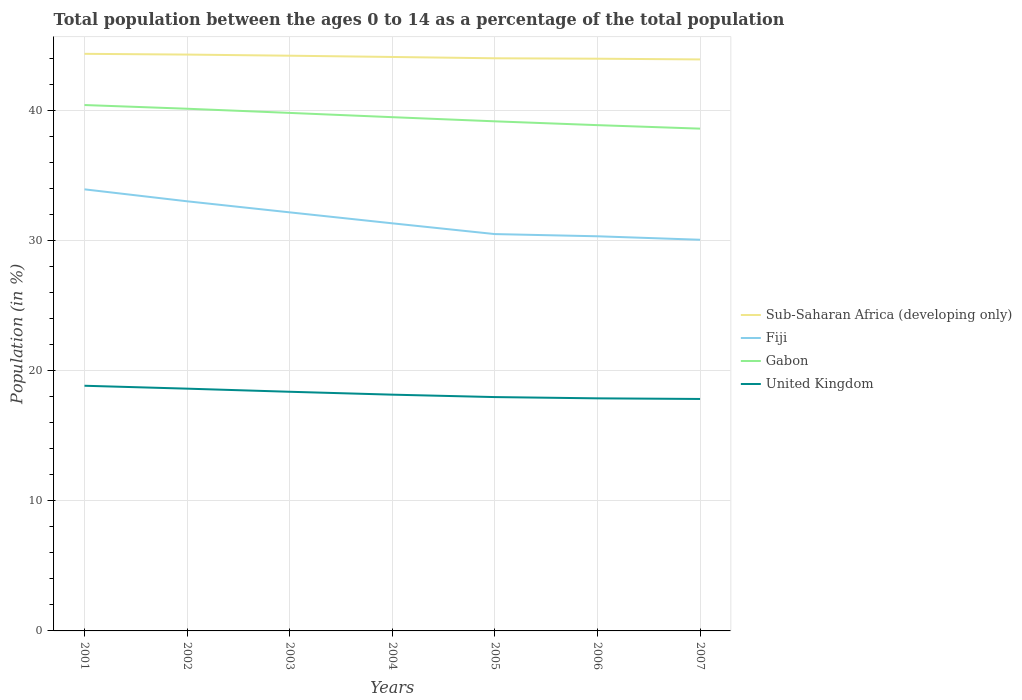Across all years, what is the maximum percentage of the population ages 0 to 14 in Fiji?
Make the answer very short. 30.09. What is the total percentage of the population ages 0 to 14 in Sub-Saharan Africa (developing only) in the graph?
Your answer should be compact. 0.1. What is the difference between the highest and the second highest percentage of the population ages 0 to 14 in Gabon?
Your response must be concise. 1.82. How many years are there in the graph?
Keep it short and to the point. 7. What is the difference between two consecutive major ticks on the Y-axis?
Your answer should be very brief. 10. Does the graph contain grids?
Make the answer very short. Yes. How are the legend labels stacked?
Your answer should be compact. Vertical. What is the title of the graph?
Give a very brief answer. Total population between the ages 0 to 14 as a percentage of the total population. What is the Population (in %) of Sub-Saharan Africa (developing only) in 2001?
Make the answer very short. 44.4. What is the Population (in %) of Fiji in 2001?
Keep it short and to the point. 33.97. What is the Population (in %) of Gabon in 2001?
Keep it short and to the point. 40.46. What is the Population (in %) in United Kingdom in 2001?
Give a very brief answer. 18.86. What is the Population (in %) in Sub-Saharan Africa (developing only) in 2002?
Provide a short and direct response. 44.34. What is the Population (in %) of Fiji in 2002?
Ensure brevity in your answer.  33.05. What is the Population (in %) of Gabon in 2002?
Provide a succinct answer. 40.17. What is the Population (in %) in United Kingdom in 2002?
Ensure brevity in your answer.  18.64. What is the Population (in %) in Sub-Saharan Africa (developing only) in 2003?
Your answer should be compact. 44.25. What is the Population (in %) of Fiji in 2003?
Your answer should be compact. 32.2. What is the Population (in %) in Gabon in 2003?
Offer a very short reply. 39.85. What is the Population (in %) of United Kingdom in 2003?
Make the answer very short. 18.4. What is the Population (in %) of Sub-Saharan Africa (developing only) in 2004?
Offer a terse response. 44.15. What is the Population (in %) of Fiji in 2004?
Provide a succinct answer. 31.36. What is the Population (in %) in Gabon in 2004?
Ensure brevity in your answer.  39.52. What is the Population (in %) of United Kingdom in 2004?
Provide a succinct answer. 18.18. What is the Population (in %) of Sub-Saharan Africa (developing only) in 2005?
Your answer should be compact. 44.05. What is the Population (in %) in Fiji in 2005?
Your answer should be compact. 30.53. What is the Population (in %) in Gabon in 2005?
Your answer should be very brief. 39.2. What is the Population (in %) in United Kingdom in 2005?
Give a very brief answer. 17.99. What is the Population (in %) of Sub-Saharan Africa (developing only) in 2006?
Offer a very short reply. 44.02. What is the Population (in %) of Fiji in 2006?
Keep it short and to the point. 30.36. What is the Population (in %) in Gabon in 2006?
Give a very brief answer. 38.91. What is the Population (in %) in United Kingdom in 2006?
Offer a terse response. 17.89. What is the Population (in %) in Sub-Saharan Africa (developing only) in 2007?
Your response must be concise. 43.97. What is the Population (in %) in Fiji in 2007?
Make the answer very short. 30.09. What is the Population (in %) in Gabon in 2007?
Provide a short and direct response. 38.64. What is the Population (in %) of United Kingdom in 2007?
Your answer should be compact. 17.84. Across all years, what is the maximum Population (in %) in Sub-Saharan Africa (developing only)?
Give a very brief answer. 44.4. Across all years, what is the maximum Population (in %) in Fiji?
Your response must be concise. 33.97. Across all years, what is the maximum Population (in %) in Gabon?
Offer a terse response. 40.46. Across all years, what is the maximum Population (in %) of United Kingdom?
Your answer should be compact. 18.86. Across all years, what is the minimum Population (in %) of Sub-Saharan Africa (developing only)?
Provide a succinct answer. 43.97. Across all years, what is the minimum Population (in %) of Fiji?
Your answer should be very brief. 30.09. Across all years, what is the minimum Population (in %) in Gabon?
Provide a succinct answer. 38.64. Across all years, what is the minimum Population (in %) of United Kingdom?
Offer a terse response. 17.84. What is the total Population (in %) of Sub-Saharan Africa (developing only) in the graph?
Your answer should be compact. 309.18. What is the total Population (in %) of Fiji in the graph?
Provide a short and direct response. 221.56. What is the total Population (in %) in Gabon in the graph?
Make the answer very short. 276.75. What is the total Population (in %) in United Kingdom in the graph?
Make the answer very short. 127.8. What is the difference between the Population (in %) of Sub-Saharan Africa (developing only) in 2001 and that in 2002?
Offer a terse response. 0.06. What is the difference between the Population (in %) of Gabon in 2001 and that in 2002?
Offer a very short reply. 0.29. What is the difference between the Population (in %) of United Kingdom in 2001 and that in 2002?
Make the answer very short. 0.22. What is the difference between the Population (in %) of Sub-Saharan Africa (developing only) in 2001 and that in 2003?
Your response must be concise. 0.14. What is the difference between the Population (in %) of Fiji in 2001 and that in 2003?
Ensure brevity in your answer.  1.77. What is the difference between the Population (in %) in Gabon in 2001 and that in 2003?
Provide a short and direct response. 0.61. What is the difference between the Population (in %) of United Kingdom in 2001 and that in 2003?
Ensure brevity in your answer.  0.46. What is the difference between the Population (in %) in Sub-Saharan Africa (developing only) in 2001 and that in 2004?
Give a very brief answer. 0.24. What is the difference between the Population (in %) of Fiji in 2001 and that in 2004?
Make the answer very short. 2.61. What is the difference between the Population (in %) in Gabon in 2001 and that in 2004?
Offer a very short reply. 0.93. What is the difference between the Population (in %) in United Kingdom in 2001 and that in 2004?
Keep it short and to the point. 0.69. What is the difference between the Population (in %) of Sub-Saharan Africa (developing only) in 2001 and that in 2005?
Ensure brevity in your answer.  0.34. What is the difference between the Population (in %) of Fiji in 2001 and that in 2005?
Make the answer very short. 3.44. What is the difference between the Population (in %) in Gabon in 2001 and that in 2005?
Your answer should be very brief. 1.25. What is the difference between the Population (in %) of United Kingdom in 2001 and that in 2005?
Keep it short and to the point. 0.87. What is the difference between the Population (in %) in Sub-Saharan Africa (developing only) in 2001 and that in 2006?
Ensure brevity in your answer.  0.37. What is the difference between the Population (in %) in Fiji in 2001 and that in 2006?
Make the answer very short. 3.61. What is the difference between the Population (in %) of Gabon in 2001 and that in 2006?
Provide a short and direct response. 1.55. What is the difference between the Population (in %) of United Kingdom in 2001 and that in 2006?
Make the answer very short. 0.97. What is the difference between the Population (in %) in Sub-Saharan Africa (developing only) in 2001 and that in 2007?
Provide a short and direct response. 0.43. What is the difference between the Population (in %) in Fiji in 2001 and that in 2007?
Your answer should be compact. 3.88. What is the difference between the Population (in %) in Gabon in 2001 and that in 2007?
Make the answer very short. 1.82. What is the difference between the Population (in %) in United Kingdom in 2001 and that in 2007?
Make the answer very short. 1.02. What is the difference between the Population (in %) in Sub-Saharan Africa (developing only) in 2002 and that in 2003?
Provide a succinct answer. 0.09. What is the difference between the Population (in %) in Fiji in 2002 and that in 2003?
Provide a succinct answer. 0.85. What is the difference between the Population (in %) of Gabon in 2002 and that in 2003?
Provide a succinct answer. 0.32. What is the difference between the Population (in %) in United Kingdom in 2002 and that in 2003?
Ensure brevity in your answer.  0.24. What is the difference between the Population (in %) in Sub-Saharan Africa (developing only) in 2002 and that in 2004?
Give a very brief answer. 0.18. What is the difference between the Population (in %) of Fiji in 2002 and that in 2004?
Offer a terse response. 1.69. What is the difference between the Population (in %) of Gabon in 2002 and that in 2004?
Offer a very short reply. 0.65. What is the difference between the Population (in %) of United Kingdom in 2002 and that in 2004?
Your answer should be compact. 0.46. What is the difference between the Population (in %) in Sub-Saharan Africa (developing only) in 2002 and that in 2005?
Give a very brief answer. 0.28. What is the difference between the Population (in %) of Fiji in 2002 and that in 2005?
Offer a very short reply. 2.52. What is the difference between the Population (in %) in Gabon in 2002 and that in 2005?
Your answer should be very brief. 0.97. What is the difference between the Population (in %) of United Kingdom in 2002 and that in 2005?
Offer a terse response. 0.65. What is the difference between the Population (in %) in Sub-Saharan Africa (developing only) in 2002 and that in 2006?
Keep it short and to the point. 0.32. What is the difference between the Population (in %) in Fiji in 2002 and that in 2006?
Give a very brief answer. 2.69. What is the difference between the Population (in %) of Gabon in 2002 and that in 2006?
Make the answer very short. 1.26. What is the difference between the Population (in %) of United Kingdom in 2002 and that in 2006?
Your answer should be very brief. 0.75. What is the difference between the Population (in %) of Sub-Saharan Africa (developing only) in 2002 and that in 2007?
Give a very brief answer. 0.37. What is the difference between the Population (in %) of Fiji in 2002 and that in 2007?
Your response must be concise. 2.96. What is the difference between the Population (in %) of Gabon in 2002 and that in 2007?
Your answer should be very brief. 1.53. What is the difference between the Population (in %) of United Kingdom in 2002 and that in 2007?
Ensure brevity in your answer.  0.79. What is the difference between the Population (in %) of Sub-Saharan Africa (developing only) in 2003 and that in 2004?
Your answer should be very brief. 0.1. What is the difference between the Population (in %) in Fiji in 2003 and that in 2004?
Ensure brevity in your answer.  0.84. What is the difference between the Population (in %) in Gabon in 2003 and that in 2004?
Ensure brevity in your answer.  0.33. What is the difference between the Population (in %) in United Kingdom in 2003 and that in 2004?
Your answer should be very brief. 0.22. What is the difference between the Population (in %) in Sub-Saharan Africa (developing only) in 2003 and that in 2005?
Provide a succinct answer. 0.2. What is the difference between the Population (in %) in Fiji in 2003 and that in 2005?
Provide a short and direct response. 1.67. What is the difference between the Population (in %) in Gabon in 2003 and that in 2005?
Provide a succinct answer. 0.65. What is the difference between the Population (in %) of United Kingdom in 2003 and that in 2005?
Offer a terse response. 0.41. What is the difference between the Population (in %) in Sub-Saharan Africa (developing only) in 2003 and that in 2006?
Give a very brief answer. 0.23. What is the difference between the Population (in %) of Fiji in 2003 and that in 2006?
Offer a terse response. 1.84. What is the difference between the Population (in %) of Gabon in 2003 and that in 2006?
Offer a very short reply. 0.94. What is the difference between the Population (in %) of United Kingdom in 2003 and that in 2006?
Your answer should be very brief. 0.51. What is the difference between the Population (in %) of Sub-Saharan Africa (developing only) in 2003 and that in 2007?
Provide a succinct answer. 0.29. What is the difference between the Population (in %) in Fiji in 2003 and that in 2007?
Your answer should be compact. 2.11. What is the difference between the Population (in %) in Gabon in 2003 and that in 2007?
Offer a very short reply. 1.21. What is the difference between the Population (in %) in United Kingdom in 2003 and that in 2007?
Give a very brief answer. 0.55. What is the difference between the Population (in %) of Sub-Saharan Africa (developing only) in 2004 and that in 2005?
Keep it short and to the point. 0.1. What is the difference between the Population (in %) of Fiji in 2004 and that in 2005?
Provide a succinct answer. 0.83. What is the difference between the Population (in %) in Gabon in 2004 and that in 2005?
Your response must be concise. 0.32. What is the difference between the Population (in %) of United Kingdom in 2004 and that in 2005?
Ensure brevity in your answer.  0.19. What is the difference between the Population (in %) of Sub-Saharan Africa (developing only) in 2004 and that in 2006?
Your response must be concise. 0.13. What is the difference between the Population (in %) in Gabon in 2004 and that in 2006?
Your response must be concise. 0.61. What is the difference between the Population (in %) of United Kingdom in 2004 and that in 2006?
Give a very brief answer. 0.28. What is the difference between the Population (in %) of Sub-Saharan Africa (developing only) in 2004 and that in 2007?
Offer a very short reply. 0.19. What is the difference between the Population (in %) of Fiji in 2004 and that in 2007?
Provide a short and direct response. 1.26. What is the difference between the Population (in %) in Gabon in 2004 and that in 2007?
Your answer should be compact. 0.88. What is the difference between the Population (in %) of United Kingdom in 2004 and that in 2007?
Ensure brevity in your answer.  0.33. What is the difference between the Population (in %) in Sub-Saharan Africa (developing only) in 2005 and that in 2006?
Your response must be concise. 0.03. What is the difference between the Population (in %) of Fiji in 2005 and that in 2006?
Keep it short and to the point. 0.17. What is the difference between the Population (in %) in Gabon in 2005 and that in 2006?
Keep it short and to the point. 0.29. What is the difference between the Population (in %) in United Kingdom in 2005 and that in 2006?
Provide a short and direct response. 0.1. What is the difference between the Population (in %) of Sub-Saharan Africa (developing only) in 2005 and that in 2007?
Provide a short and direct response. 0.09. What is the difference between the Population (in %) of Fiji in 2005 and that in 2007?
Your answer should be very brief. 0.44. What is the difference between the Population (in %) in Gabon in 2005 and that in 2007?
Keep it short and to the point. 0.56. What is the difference between the Population (in %) in United Kingdom in 2005 and that in 2007?
Offer a terse response. 0.15. What is the difference between the Population (in %) in Sub-Saharan Africa (developing only) in 2006 and that in 2007?
Make the answer very short. 0.06. What is the difference between the Population (in %) in Fiji in 2006 and that in 2007?
Provide a short and direct response. 0.27. What is the difference between the Population (in %) in Gabon in 2006 and that in 2007?
Provide a succinct answer. 0.27. What is the difference between the Population (in %) in United Kingdom in 2006 and that in 2007?
Provide a short and direct response. 0.05. What is the difference between the Population (in %) of Sub-Saharan Africa (developing only) in 2001 and the Population (in %) of Fiji in 2002?
Offer a terse response. 11.34. What is the difference between the Population (in %) of Sub-Saharan Africa (developing only) in 2001 and the Population (in %) of Gabon in 2002?
Keep it short and to the point. 4.22. What is the difference between the Population (in %) of Sub-Saharan Africa (developing only) in 2001 and the Population (in %) of United Kingdom in 2002?
Your answer should be compact. 25.76. What is the difference between the Population (in %) in Fiji in 2001 and the Population (in %) in Gabon in 2002?
Your response must be concise. -6.2. What is the difference between the Population (in %) in Fiji in 2001 and the Population (in %) in United Kingdom in 2002?
Provide a short and direct response. 15.33. What is the difference between the Population (in %) of Gabon in 2001 and the Population (in %) of United Kingdom in 2002?
Make the answer very short. 21.82. What is the difference between the Population (in %) in Sub-Saharan Africa (developing only) in 2001 and the Population (in %) in Fiji in 2003?
Offer a terse response. 12.2. What is the difference between the Population (in %) of Sub-Saharan Africa (developing only) in 2001 and the Population (in %) of Gabon in 2003?
Ensure brevity in your answer.  4.54. What is the difference between the Population (in %) of Sub-Saharan Africa (developing only) in 2001 and the Population (in %) of United Kingdom in 2003?
Provide a succinct answer. 26. What is the difference between the Population (in %) of Fiji in 2001 and the Population (in %) of Gabon in 2003?
Give a very brief answer. -5.88. What is the difference between the Population (in %) in Fiji in 2001 and the Population (in %) in United Kingdom in 2003?
Offer a very short reply. 15.57. What is the difference between the Population (in %) of Gabon in 2001 and the Population (in %) of United Kingdom in 2003?
Give a very brief answer. 22.06. What is the difference between the Population (in %) in Sub-Saharan Africa (developing only) in 2001 and the Population (in %) in Fiji in 2004?
Give a very brief answer. 13.04. What is the difference between the Population (in %) in Sub-Saharan Africa (developing only) in 2001 and the Population (in %) in Gabon in 2004?
Give a very brief answer. 4.87. What is the difference between the Population (in %) of Sub-Saharan Africa (developing only) in 2001 and the Population (in %) of United Kingdom in 2004?
Ensure brevity in your answer.  26.22. What is the difference between the Population (in %) in Fiji in 2001 and the Population (in %) in Gabon in 2004?
Your answer should be compact. -5.55. What is the difference between the Population (in %) of Fiji in 2001 and the Population (in %) of United Kingdom in 2004?
Offer a terse response. 15.8. What is the difference between the Population (in %) of Gabon in 2001 and the Population (in %) of United Kingdom in 2004?
Make the answer very short. 22.28. What is the difference between the Population (in %) in Sub-Saharan Africa (developing only) in 2001 and the Population (in %) in Fiji in 2005?
Offer a terse response. 13.87. What is the difference between the Population (in %) in Sub-Saharan Africa (developing only) in 2001 and the Population (in %) in Gabon in 2005?
Provide a succinct answer. 5.19. What is the difference between the Population (in %) of Sub-Saharan Africa (developing only) in 2001 and the Population (in %) of United Kingdom in 2005?
Offer a very short reply. 26.41. What is the difference between the Population (in %) in Fiji in 2001 and the Population (in %) in Gabon in 2005?
Offer a very short reply. -5.23. What is the difference between the Population (in %) of Fiji in 2001 and the Population (in %) of United Kingdom in 2005?
Provide a succinct answer. 15.98. What is the difference between the Population (in %) of Gabon in 2001 and the Population (in %) of United Kingdom in 2005?
Your answer should be very brief. 22.47. What is the difference between the Population (in %) of Sub-Saharan Africa (developing only) in 2001 and the Population (in %) of Fiji in 2006?
Keep it short and to the point. 14.04. What is the difference between the Population (in %) of Sub-Saharan Africa (developing only) in 2001 and the Population (in %) of Gabon in 2006?
Offer a very short reply. 5.49. What is the difference between the Population (in %) of Sub-Saharan Africa (developing only) in 2001 and the Population (in %) of United Kingdom in 2006?
Your answer should be very brief. 26.5. What is the difference between the Population (in %) of Fiji in 2001 and the Population (in %) of Gabon in 2006?
Offer a very short reply. -4.94. What is the difference between the Population (in %) in Fiji in 2001 and the Population (in %) in United Kingdom in 2006?
Offer a terse response. 16.08. What is the difference between the Population (in %) of Gabon in 2001 and the Population (in %) of United Kingdom in 2006?
Your response must be concise. 22.57. What is the difference between the Population (in %) in Sub-Saharan Africa (developing only) in 2001 and the Population (in %) in Fiji in 2007?
Ensure brevity in your answer.  14.3. What is the difference between the Population (in %) in Sub-Saharan Africa (developing only) in 2001 and the Population (in %) in Gabon in 2007?
Your response must be concise. 5.76. What is the difference between the Population (in %) of Sub-Saharan Africa (developing only) in 2001 and the Population (in %) of United Kingdom in 2007?
Give a very brief answer. 26.55. What is the difference between the Population (in %) of Fiji in 2001 and the Population (in %) of Gabon in 2007?
Keep it short and to the point. -4.67. What is the difference between the Population (in %) in Fiji in 2001 and the Population (in %) in United Kingdom in 2007?
Keep it short and to the point. 16.13. What is the difference between the Population (in %) in Gabon in 2001 and the Population (in %) in United Kingdom in 2007?
Ensure brevity in your answer.  22.61. What is the difference between the Population (in %) in Sub-Saharan Africa (developing only) in 2002 and the Population (in %) in Fiji in 2003?
Your answer should be compact. 12.14. What is the difference between the Population (in %) in Sub-Saharan Africa (developing only) in 2002 and the Population (in %) in Gabon in 2003?
Offer a very short reply. 4.49. What is the difference between the Population (in %) in Sub-Saharan Africa (developing only) in 2002 and the Population (in %) in United Kingdom in 2003?
Your response must be concise. 25.94. What is the difference between the Population (in %) of Fiji in 2002 and the Population (in %) of Gabon in 2003?
Your answer should be compact. -6.8. What is the difference between the Population (in %) of Fiji in 2002 and the Population (in %) of United Kingdom in 2003?
Provide a succinct answer. 14.65. What is the difference between the Population (in %) of Gabon in 2002 and the Population (in %) of United Kingdom in 2003?
Provide a short and direct response. 21.77. What is the difference between the Population (in %) in Sub-Saharan Africa (developing only) in 2002 and the Population (in %) in Fiji in 2004?
Provide a succinct answer. 12.98. What is the difference between the Population (in %) in Sub-Saharan Africa (developing only) in 2002 and the Population (in %) in Gabon in 2004?
Make the answer very short. 4.82. What is the difference between the Population (in %) of Sub-Saharan Africa (developing only) in 2002 and the Population (in %) of United Kingdom in 2004?
Provide a short and direct response. 26.16. What is the difference between the Population (in %) in Fiji in 2002 and the Population (in %) in Gabon in 2004?
Offer a very short reply. -6.47. What is the difference between the Population (in %) in Fiji in 2002 and the Population (in %) in United Kingdom in 2004?
Offer a terse response. 14.88. What is the difference between the Population (in %) in Gabon in 2002 and the Population (in %) in United Kingdom in 2004?
Provide a succinct answer. 22. What is the difference between the Population (in %) of Sub-Saharan Africa (developing only) in 2002 and the Population (in %) of Fiji in 2005?
Your answer should be very brief. 13.81. What is the difference between the Population (in %) of Sub-Saharan Africa (developing only) in 2002 and the Population (in %) of Gabon in 2005?
Ensure brevity in your answer.  5.14. What is the difference between the Population (in %) in Sub-Saharan Africa (developing only) in 2002 and the Population (in %) in United Kingdom in 2005?
Provide a short and direct response. 26.35. What is the difference between the Population (in %) of Fiji in 2002 and the Population (in %) of Gabon in 2005?
Provide a succinct answer. -6.15. What is the difference between the Population (in %) of Fiji in 2002 and the Population (in %) of United Kingdom in 2005?
Offer a terse response. 15.06. What is the difference between the Population (in %) in Gabon in 2002 and the Population (in %) in United Kingdom in 2005?
Make the answer very short. 22.18. What is the difference between the Population (in %) of Sub-Saharan Africa (developing only) in 2002 and the Population (in %) of Fiji in 2006?
Make the answer very short. 13.98. What is the difference between the Population (in %) of Sub-Saharan Africa (developing only) in 2002 and the Population (in %) of Gabon in 2006?
Ensure brevity in your answer.  5.43. What is the difference between the Population (in %) of Sub-Saharan Africa (developing only) in 2002 and the Population (in %) of United Kingdom in 2006?
Your response must be concise. 26.45. What is the difference between the Population (in %) of Fiji in 2002 and the Population (in %) of Gabon in 2006?
Your answer should be compact. -5.86. What is the difference between the Population (in %) in Fiji in 2002 and the Population (in %) in United Kingdom in 2006?
Offer a terse response. 15.16. What is the difference between the Population (in %) of Gabon in 2002 and the Population (in %) of United Kingdom in 2006?
Make the answer very short. 22.28. What is the difference between the Population (in %) of Sub-Saharan Africa (developing only) in 2002 and the Population (in %) of Fiji in 2007?
Keep it short and to the point. 14.24. What is the difference between the Population (in %) in Sub-Saharan Africa (developing only) in 2002 and the Population (in %) in Gabon in 2007?
Keep it short and to the point. 5.7. What is the difference between the Population (in %) in Sub-Saharan Africa (developing only) in 2002 and the Population (in %) in United Kingdom in 2007?
Offer a terse response. 26.49. What is the difference between the Population (in %) of Fiji in 2002 and the Population (in %) of Gabon in 2007?
Offer a terse response. -5.59. What is the difference between the Population (in %) of Fiji in 2002 and the Population (in %) of United Kingdom in 2007?
Give a very brief answer. 15.21. What is the difference between the Population (in %) in Gabon in 2002 and the Population (in %) in United Kingdom in 2007?
Provide a succinct answer. 22.33. What is the difference between the Population (in %) in Sub-Saharan Africa (developing only) in 2003 and the Population (in %) in Fiji in 2004?
Provide a succinct answer. 12.9. What is the difference between the Population (in %) in Sub-Saharan Africa (developing only) in 2003 and the Population (in %) in Gabon in 2004?
Your answer should be very brief. 4.73. What is the difference between the Population (in %) of Sub-Saharan Africa (developing only) in 2003 and the Population (in %) of United Kingdom in 2004?
Offer a very short reply. 26.08. What is the difference between the Population (in %) in Fiji in 2003 and the Population (in %) in Gabon in 2004?
Give a very brief answer. -7.32. What is the difference between the Population (in %) of Fiji in 2003 and the Population (in %) of United Kingdom in 2004?
Provide a short and direct response. 14.02. What is the difference between the Population (in %) in Gabon in 2003 and the Population (in %) in United Kingdom in 2004?
Your response must be concise. 21.68. What is the difference between the Population (in %) of Sub-Saharan Africa (developing only) in 2003 and the Population (in %) of Fiji in 2005?
Provide a short and direct response. 13.72. What is the difference between the Population (in %) of Sub-Saharan Africa (developing only) in 2003 and the Population (in %) of Gabon in 2005?
Keep it short and to the point. 5.05. What is the difference between the Population (in %) in Sub-Saharan Africa (developing only) in 2003 and the Population (in %) in United Kingdom in 2005?
Provide a short and direct response. 26.26. What is the difference between the Population (in %) of Fiji in 2003 and the Population (in %) of Gabon in 2005?
Your answer should be very brief. -7. What is the difference between the Population (in %) in Fiji in 2003 and the Population (in %) in United Kingdom in 2005?
Your answer should be very brief. 14.21. What is the difference between the Population (in %) in Gabon in 2003 and the Population (in %) in United Kingdom in 2005?
Ensure brevity in your answer.  21.86. What is the difference between the Population (in %) of Sub-Saharan Africa (developing only) in 2003 and the Population (in %) of Fiji in 2006?
Your response must be concise. 13.89. What is the difference between the Population (in %) of Sub-Saharan Africa (developing only) in 2003 and the Population (in %) of Gabon in 2006?
Give a very brief answer. 5.34. What is the difference between the Population (in %) of Sub-Saharan Africa (developing only) in 2003 and the Population (in %) of United Kingdom in 2006?
Keep it short and to the point. 26.36. What is the difference between the Population (in %) of Fiji in 2003 and the Population (in %) of Gabon in 2006?
Your answer should be very brief. -6.71. What is the difference between the Population (in %) in Fiji in 2003 and the Population (in %) in United Kingdom in 2006?
Your answer should be very brief. 14.31. What is the difference between the Population (in %) in Gabon in 2003 and the Population (in %) in United Kingdom in 2006?
Your response must be concise. 21.96. What is the difference between the Population (in %) in Sub-Saharan Africa (developing only) in 2003 and the Population (in %) in Fiji in 2007?
Your answer should be very brief. 14.16. What is the difference between the Population (in %) of Sub-Saharan Africa (developing only) in 2003 and the Population (in %) of Gabon in 2007?
Offer a terse response. 5.61. What is the difference between the Population (in %) of Sub-Saharan Africa (developing only) in 2003 and the Population (in %) of United Kingdom in 2007?
Make the answer very short. 26.41. What is the difference between the Population (in %) of Fiji in 2003 and the Population (in %) of Gabon in 2007?
Your answer should be very brief. -6.44. What is the difference between the Population (in %) in Fiji in 2003 and the Population (in %) in United Kingdom in 2007?
Offer a very short reply. 14.36. What is the difference between the Population (in %) in Gabon in 2003 and the Population (in %) in United Kingdom in 2007?
Provide a short and direct response. 22.01. What is the difference between the Population (in %) in Sub-Saharan Africa (developing only) in 2004 and the Population (in %) in Fiji in 2005?
Make the answer very short. 13.63. What is the difference between the Population (in %) of Sub-Saharan Africa (developing only) in 2004 and the Population (in %) of Gabon in 2005?
Your answer should be compact. 4.95. What is the difference between the Population (in %) of Sub-Saharan Africa (developing only) in 2004 and the Population (in %) of United Kingdom in 2005?
Your answer should be compact. 26.16. What is the difference between the Population (in %) in Fiji in 2004 and the Population (in %) in Gabon in 2005?
Your answer should be very brief. -7.85. What is the difference between the Population (in %) in Fiji in 2004 and the Population (in %) in United Kingdom in 2005?
Provide a short and direct response. 13.37. What is the difference between the Population (in %) of Gabon in 2004 and the Population (in %) of United Kingdom in 2005?
Provide a succinct answer. 21.53. What is the difference between the Population (in %) of Sub-Saharan Africa (developing only) in 2004 and the Population (in %) of Fiji in 2006?
Make the answer very short. 13.79. What is the difference between the Population (in %) of Sub-Saharan Africa (developing only) in 2004 and the Population (in %) of Gabon in 2006?
Give a very brief answer. 5.24. What is the difference between the Population (in %) of Sub-Saharan Africa (developing only) in 2004 and the Population (in %) of United Kingdom in 2006?
Your answer should be compact. 26.26. What is the difference between the Population (in %) of Fiji in 2004 and the Population (in %) of Gabon in 2006?
Make the answer very short. -7.55. What is the difference between the Population (in %) of Fiji in 2004 and the Population (in %) of United Kingdom in 2006?
Your answer should be compact. 13.46. What is the difference between the Population (in %) in Gabon in 2004 and the Population (in %) in United Kingdom in 2006?
Provide a succinct answer. 21.63. What is the difference between the Population (in %) in Sub-Saharan Africa (developing only) in 2004 and the Population (in %) in Fiji in 2007?
Provide a short and direct response. 14.06. What is the difference between the Population (in %) in Sub-Saharan Africa (developing only) in 2004 and the Population (in %) in Gabon in 2007?
Your answer should be compact. 5.51. What is the difference between the Population (in %) of Sub-Saharan Africa (developing only) in 2004 and the Population (in %) of United Kingdom in 2007?
Offer a terse response. 26.31. What is the difference between the Population (in %) in Fiji in 2004 and the Population (in %) in Gabon in 2007?
Your answer should be compact. -7.28. What is the difference between the Population (in %) of Fiji in 2004 and the Population (in %) of United Kingdom in 2007?
Your answer should be compact. 13.51. What is the difference between the Population (in %) in Gabon in 2004 and the Population (in %) in United Kingdom in 2007?
Your answer should be compact. 21.68. What is the difference between the Population (in %) in Sub-Saharan Africa (developing only) in 2005 and the Population (in %) in Fiji in 2006?
Give a very brief answer. 13.69. What is the difference between the Population (in %) in Sub-Saharan Africa (developing only) in 2005 and the Population (in %) in Gabon in 2006?
Provide a succinct answer. 5.14. What is the difference between the Population (in %) of Sub-Saharan Africa (developing only) in 2005 and the Population (in %) of United Kingdom in 2006?
Offer a very short reply. 26.16. What is the difference between the Population (in %) in Fiji in 2005 and the Population (in %) in Gabon in 2006?
Offer a very short reply. -8.38. What is the difference between the Population (in %) of Fiji in 2005 and the Population (in %) of United Kingdom in 2006?
Offer a terse response. 12.64. What is the difference between the Population (in %) in Gabon in 2005 and the Population (in %) in United Kingdom in 2006?
Make the answer very short. 21.31. What is the difference between the Population (in %) of Sub-Saharan Africa (developing only) in 2005 and the Population (in %) of Fiji in 2007?
Make the answer very short. 13.96. What is the difference between the Population (in %) in Sub-Saharan Africa (developing only) in 2005 and the Population (in %) in Gabon in 2007?
Your response must be concise. 5.41. What is the difference between the Population (in %) in Sub-Saharan Africa (developing only) in 2005 and the Population (in %) in United Kingdom in 2007?
Your answer should be compact. 26.21. What is the difference between the Population (in %) in Fiji in 2005 and the Population (in %) in Gabon in 2007?
Your answer should be very brief. -8.11. What is the difference between the Population (in %) of Fiji in 2005 and the Population (in %) of United Kingdom in 2007?
Give a very brief answer. 12.69. What is the difference between the Population (in %) of Gabon in 2005 and the Population (in %) of United Kingdom in 2007?
Provide a short and direct response. 21.36. What is the difference between the Population (in %) in Sub-Saharan Africa (developing only) in 2006 and the Population (in %) in Fiji in 2007?
Offer a terse response. 13.93. What is the difference between the Population (in %) of Sub-Saharan Africa (developing only) in 2006 and the Population (in %) of Gabon in 2007?
Your answer should be compact. 5.38. What is the difference between the Population (in %) in Sub-Saharan Africa (developing only) in 2006 and the Population (in %) in United Kingdom in 2007?
Offer a very short reply. 26.18. What is the difference between the Population (in %) in Fiji in 2006 and the Population (in %) in Gabon in 2007?
Keep it short and to the point. -8.28. What is the difference between the Population (in %) of Fiji in 2006 and the Population (in %) of United Kingdom in 2007?
Your response must be concise. 12.52. What is the difference between the Population (in %) of Gabon in 2006 and the Population (in %) of United Kingdom in 2007?
Keep it short and to the point. 21.07. What is the average Population (in %) in Sub-Saharan Africa (developing only) per year?
Your answer should be compact. 44.17. What is the average Population (in %) in Fiji per year?
Provide a succinct answer. 31.65. What is the average Population (in %) of Gabon per year?
Offer a terse response. 39.54. What is the average Population (in %) of United Kingdom per year?
Your answer should be very brief. 18.26. In the year 2001, what is the difference between the Population (in %) of Sub-Saharan Africa (developing only) and Population (in %) of Fiji?
Provide a succinct answer. 10.42. In the year 2001, what is the difference between the Population (in %) in Sub-Saharan Africa (developing only) and Population (in %) in Gabon?
Your response must be concise. 3.94. In the year 2001, what is the difference between the Population (in %) of Sub-Saharan Africa (developing only) and Population (in %) of United Kingdom?
Provide a succinct answer. 25.53. In the year 2001, what is the difference between the Population (in %) in Fiji and Population (in %) in Gabon?
Give a very brief answer. -6.49. In the year 2001, what is the difference between the Population (in %) in Fiji and Population (in %) in United Kingdom?
Offer a very short reply. 15.11. In the year 2001, what is the difference between the Population (in %) in Gabon and Population (in %) in United Kingdom?
Offer a terse response. 21.6. In the year 2002, what is the difference between the Population (in %) in Sub-Saharan Africa (developing only) and Population (in %) in Fiji?
Offer a terse response. 11.29. In the year 2002, what is the difference between the Population (in %) of Sub-Saharan Africa (developing only) and Population (in %) of Gabon?
Provide a short and direct response. 4.17. In the year 2002, what is the difference between the Population (in %) of Sub-Saharan Africa (developing only) and Population (in %) of United Kingdom?
Your answer should be compact. 25.7. In the year 2002, what is the difference between the Population (in %) of Fiji and Population (in %) of Gabon?
Give a very brief answer. -7.12. In the year 2002, what is the difference between the Population (in %) of Fiji and Population (in %) of United Kingdom?
Provide a short and direct response. 14.41. In the year 2002, what is the difference between the Population (in %) of Gabon and Population (in %) of United Kingdom?
Provide a short and direct response. 21.53. In the year 2003, what is the difference between the Population (in %) in Sub-Saharan Africa (developing only) and Population (in %) in Fiji?
Your answer should be very brief. 12.05. In the year 2003, what is the difference between the Population (in %) of Sub-Saharan Africa (developing only) and Population (in %) of Gabon?
Your answer should be very brief. 4.4. In the year 2003, what is the difference between the Population (in %) of Sub-Saharan Africa (developing only) and Population (in %) of United Kingdom?
Your answer should be compact. 25.85. In the year 2003, what is the difference between the Population (in %) in Fiji and Population (in %) in Gabon?
Your answer should be very brief. -7.65. In the year 2003, what is the difference between the Population (in %) in Fiji and Population (in %) in United Kingdom?
Provide a short and direct response. 13.8. In the year 2003, what is the difference between the Population (in %) of Gabon and Population (in %) of United Kingdom?
Make the answer very short. 21.45. In the year 2004, what is the difference between the Population (in %) in Sub-Saharan Africa (developing only) and Population (in %) in Fiji?
Offer a terse response. 12.8. In the year 2004, what is the difference between the Population (in %) of Sub-Saharan Africa (developing only) and Population (in %) of Gabon?
Make the answer very short. 4.63. In the year 2004, what is the difference between the Population (in %) in Sub-Saharan Africa (developing only) and Population (in %) in United Kingdom?
Your answer should be very brief. 25.98. In the year 2004, what is the difference between the Population (in %) in Fiji and Population (in %) in Gabon?
Your answer should be compact. -8.17. In the year 2004, what is the difference between the Population (in %) in Fiji and Population (in %) in United Kingdom?
Your answer should be compact. 13.18. In the year 2004, what is the difference between the Population (in %) of Gabon and Population (in %) of United Kingdom?
Provide a short and direct response. 21.35. In the year 2005, what is the difference between the Population (in %) of Sub-Saharan Africa (developing only) and Population (in %) of Fiji?
Give a very brief answer. 13.52. In the year 2005, what is the difference between the Population (in %) in Sub-Saharan Africa (developing only) and Population (in %) in Gabon?
Offer a terse response. 4.85. In the year 2005, what is the difference between the Population (in %) of Sub-Saharan Africa (developing only) and Population (in %) of United Kingdom?
Offer a terse response. 26.06. In the year 2005, what is the difference between the Population (in %) of Fiji and Population (in %) of Gabon?
Offer a very short reply. -8.67. In the year 2005, what is the difference between the Population (in %) of Fiji and Population (in %) of United Kingdom?
Your answer should be very brief. 12.54. In the year 2005, what is the difference between the Population (in %) in Gabon and Population (in %) in United Kingdom?
Offer a terse response. 21.21. In the year 2006, what is the difference between the Population (in %) of Sub-Saharan Africa (developing only) and Population (in %) of Fiji?
Provide a short and direct response. 13.66. In the year 2006, what is the difference between the Population (in %) of Sub-Saharan Africa (developing only) and Population (in %) of Gabon?
Provide a short and direct response. 5.11. In the year 2006, what is the difference between the Population (in %) of Sub-Saharan Africa (developing only) and Population (in %) of United Kingdom?
Give a very brief answer. 26.13. In the year 2006, what is the difference between the Population (in %) of Fiji and Population (in %) of Gabon?
Provide a succinct answer. -8.55. In the year 2006, what is the difference between the Population (in %) of Fiji and Population (in %) of United Kingdom?
Give a very brief answer. 12.47. In the year 2006, what is the difference between the Population (in %) of Gabon and Population (in %) of United Kingdom?
Offer a terse response. 21.02. In the year 2007, what is the difference between the Population (in %) in Sub-Saharan Africa (developing only) and Population (in %) in Fiji?
Provide a succinct answer. 13.87. In the year 2007, what is the difference between the Population (in %) in Sub-Saharan Africa (developing only) and Population (in %) in Gabon?
Keep it short and to the point. 5.33. In the year 2007, what is the difference between the Population (in %) in Sub-Saharan Africa (developing only) and Population (in %) in United Kingdom?
Provide a short and direct response. 26.12. In the year 2007, what is the difference between the Population (in %) in Fiji and Population (in %) in Gabon?
Provide a short and direct response. -8.55. In the year 2007, what is the difference between the Population (in %) in Fiji and Population (in %) in United Kingdom?
Offer a very short reply. 12.25. In the year 2007, what is the difference between the Population (in %) of Gabon and Population (in %) of United Kingdom?
Give a very brief answer. 20.8. What is the ratio of the Population (in %) of Sub-Saharan Africa (developing only) in 2001 to that in 2002?
Offer a very short reply. 1. What is the ratio of the Population (in %) of Fiji in 2001 to that in 2002?
Your response must be concise. 1.03. What is the ratio of the Population (in %) of Gabon in 2001 to that in 2002?
Your answer should be compact. 1.01. What is the ratio of the Population (in %) in Sub-Saharan Africa (developing only) in 2001 to that in 2003?
Your response must be concise. 1. What is the ratio of the Population (in %) of Fiji in 2001 to that in 2003?
Your response must be concise. 1.05. What is the ratio of the Population (in %) in Gabon in 2001 to that in 2003?
Your answer should be very brief. 1.02. What is the ratio of the Population (in %) in United Kingdom in 2001 to that in 2003?
Your answer should be very brief. 1.03. What is the ratio of the Population (in %) of Fiji in 2001 to that in 2004?
Your answer should be very brief. 1.08. What is the ratio of the Population (in %) of Gabon in 2001 to that in 2004?
Offer a terse response. 1.02. What is the ratio of the Population (in %) in United Kingdom in 2001 to that in 2004?
Offer a terse response. 1.04. What is the ratio of the Population (in %) in Fiji in 2001 to that in 2005?
Provide a short and direct response. 1.11. What is the ratio of the Population (in %) in Gabon in 2001 to that in 2005?
Keep it short and to the point. 1.03. What is the ratio of the Population (in %) of United Kingdom in 2001 to that in 2005?
Provide a short and direct response. 1.05. What is the ratio of the Population (in %) in Sub-Saharan Africa (developing only) in 2001 to that in 2006?
Give a very brief answer. 1.01. What is the ratio of the Population (in %) of Fiji in 2001 to that in 2006?
Your answer should be very brief. 1.12. What is the ratio of the Population (in %) of Gabon in 2001 to that in 2006?
Ensure brevity in your answer.  1.04. What is the ratio of the Population (in %) in United Kingdom in 2001 to that in 2006?
Give a very brief answer. 1.05. What is the ratio of the Population (in %) in Sub-Saharan Africa (developing only) in 2001 to that in 2007?
Your answer should be very brief. 1.01. What is the ratio of the Population (in %) of Fiji in 2001 to that in 2007?
Provide a short and direct response. 1.13. What is the ratio of the Population (in %) of Gabon in 2001 to that in 2007?
Offer a very short reply. 1.05. What is the ratio of the Population (in %) in United Kingdom in 2001 to that in 2007?
Offer a terse response. 1.06. What is the ratio of the Population (in %) of Sub-Saharan Africa (developing only) in 2002 to that in 2003?
Make the answer very short. 1. What is the ratio of the Population (in %) of Fiji in 2002 to that in 2003?
Offer a terse response. 1.03. What is the ratio of the Population (in %) in Gabon in 2002 to that in 2003?
Keep it short and to the point. 1.01. What is the ratio of the Population (in %) in Sub-Saharan Africa (developing only) in 2002 to that in 2004?
Your response must be concise. 1. What is the ratio of the Population (in %) of Fiji in 2002 to that in 2004?
Your answer should be compact. 1.05. What is the ratio of the Population (in %) in Gabon in 2002 to that in 2004?
Make the answer very short. 1.02. What is the ratio of the Population (in %) in United Kingdom in 2002 to that in 2004?
Make the answer very short. 1.03. What is the ratio of the Population (in %) in Fiji in 2002 to that in 2005?
Your answer should be compact. 1.08. What is the ratio of the Population (in %) of Gabon in 2002 to that in 2005?
Your answer should be compact. 1.02. What is the ratio of the Population (in %) of United Kingdom in 2002 to that in 2005?
Your answer should be very brief. 1.04. What is the ratio of the Population (in %) in Fiji in 2002 to that in 2006?
Offer a very short reply. 1.09. What is the ratio of the Population (in %) of Gabon in 2002 to that in 2006?
Your response must be concise. 1.03. What is the ratio of the Population (in %) in United Kingdom in 2002 to that in 2006?
Ensure brevity in your answer.  1.04. What is the ratio of the Population (in %) of Sub-Saharan Africa (developing only) in 2002 to that in 2007?
Give a very brief answer. 1.01. What is the ratio of the Population (in %) in Fiji in 2002 to that in 2007?
Your answer should be compact. 1.1. What is the ratio of the Population (in %) of Gabon in 2002 to that in 2007?
Your answer should be compact. 1.04. What is the ratio of the Population (in %) in United Kingdom in 2002 to that in 2007?
Ensure brevity in your answer.  1.04. What is the ratio of the Population (in %) in Sub-Saharan Africa (developing only) in 2003 to that in 2004?
Give a very brief answer. 1. What is the ratio of the Population (in %) of Fiji in 2003 to that in 2004?
Offer a very short reply. 1.03. What is the ratio of the Population (in %) of Gabon in 2003 to that in 2004?
Ensure brevity in your answer.  1.01. What is the ratio of the Population (in %) of United Kingdom in 2003 to that in 2004?
Make the answer very short. 1.01. What is the ratio of the Population (in %) of Fiji in 2003 to that in 2005?
Offer a terse response. 1.05. What is the ratio of the Population (in %) of Gabon in 2003 to that in 2005?
Offer a terse response. 1.02. What is the ratio of the Population (in %) in United Kingdom in 2003 to that in 2005?
Offer a terse response. 1.02. What is the ratio of the Population (in %) of Sub-Saharan Africa (developing only) in 2003 to that in 2006?
Keep it short and to the point. 1.01. What is the ratio of the Population (in %) of Fiji in 2003 to that in 2006?
Your response must be concise. 1.06. What is the ratio of the Population (in %) of Gabon in 2003 to that in 2006?
Your response must be concise. 1.02. What is the ratio of the Population (in %) in United Kingdom in 2003 to that in 2006?
Make the answer very short. 1.03. What is the ratio of the Population (in %) in Sub-Saharan Africa (developing only) in 2003 to that in 2007?
Make the answer very short. 1.01. What is the ratio of the Population (in %) in Fiji in 2003 to that in 2007?
Provide a short and direct response. 1.07. What is the ratio of the Population (in %) in Gabon in 2003 to that in 2007?
Your answer should be very brief. 1.03. What is the ratio of the Population (in %) of United Kingdom in 2003 to that in 2007?
Offer a terse response. 1.03. What is the ratio of the Population (in %) in Sub-Saharan Africa (developing only) in 2004 to that in 2005?
Ensure brevity in your answer.  1. What is the ratio of the Population (in %) of Fiji in 2004 to that in 2005?
Provide a succinct answer. 1.03. What is the ratio of the Population (in %) of Gabon in 2004 to that in 2005?
Make the answer very short. 1.01. What is the ratio of the Population (in %) of United Kingdom in 2004 to that in 2005?
Provide a succinct answer. 1.01. What is the ratio of the Population (in %) in Sub-Saharan Africa (developing only) in 2004 to that in 2006?
Provide a short and direct response. 1. What is the ratio of the Population (in %) in Fiji in 2004 to that in 2006?
Your answer should be very brief. 1.03. What is the ratio of the Population (in %) in Gabon in 2004 to that in 2006?
Offer a terse response. 1.02. What is the ratio of the Population (in %) of United Kingdom in 2004 to that in 2006?
Give a very brief answer. 1.02. What is the ratio of the Population (in %) in Fiji in 2004 to that in 2007?
Provide a short and direct response. 1.04. What is the ratio of the Population (in %) of Gabon in 2004 to that in 2007?
Your answer should be very brief. 1.02. What is the ratio of the Population (in %) in United Kingdom in 2004 to that in 2007?
Give a very brief answer. 1.02. What is the ratio of the Population (in %) of Sub-Saharan Africa (developing only) in 2005 to that in 2006?
Provide a succinct answer. 1. What is the ratio of the Population (in %) in Fiji in 2005 to that in 2006?
Your answer should be compact. 1.01. What is the ratio of the Population (in %) in Gabon in 2005 to that in 2006?
Provide a succinct answer. 1.01. What is the ratio of the Population (in %) in Fiji in 2005 to that in 2007?
Make the answer very short. 1.01. What is the ratio of the Population (in %) of Gabon in 2005 to that in 2007?
Offer a terse response. 1.01. What is the ratio of the Population (in %) in United Kingdom in 2005 to that in 2007?
Provide a succinct answer. 1.01. What is the ratio of the Population (in %) of Fiji in 2006 to that in 2007?
Your response must be concise. 1.01. What is the ratio of the Population (in %) of United Kingdom in 2006 to that in 2007?
Your response must be concise. 1. What is the difference between the highest and the second highest Population (in %) of Sub-Saharan Africa (developing only)?
Give a very brief answer. 0.06. What is the difference between the highest and the second highest Population (in %) in Gabon?
Make the answer very short. 0.29. What is the difference between the highest and the second highest Population (in %) in United Kingdom?
Keep it short and to the point. 0.22. What is the difference between the highest and the lowest Population (in %) of Sub-Saharan Africa (developing only)?
Ensure brevity in your answer.  0.43. What is the difference between the highest and the lowest Population (in %) in Fiji?
Your response must be concise. 3.88. What is the difference between the highest and the lowest Population (in %) of Gabon?
Provide a short and direct response. 1.82. What is the difference between the highest and the lowest Population (in %) in United Kingdom?
Make the answer very short. 1.02. 